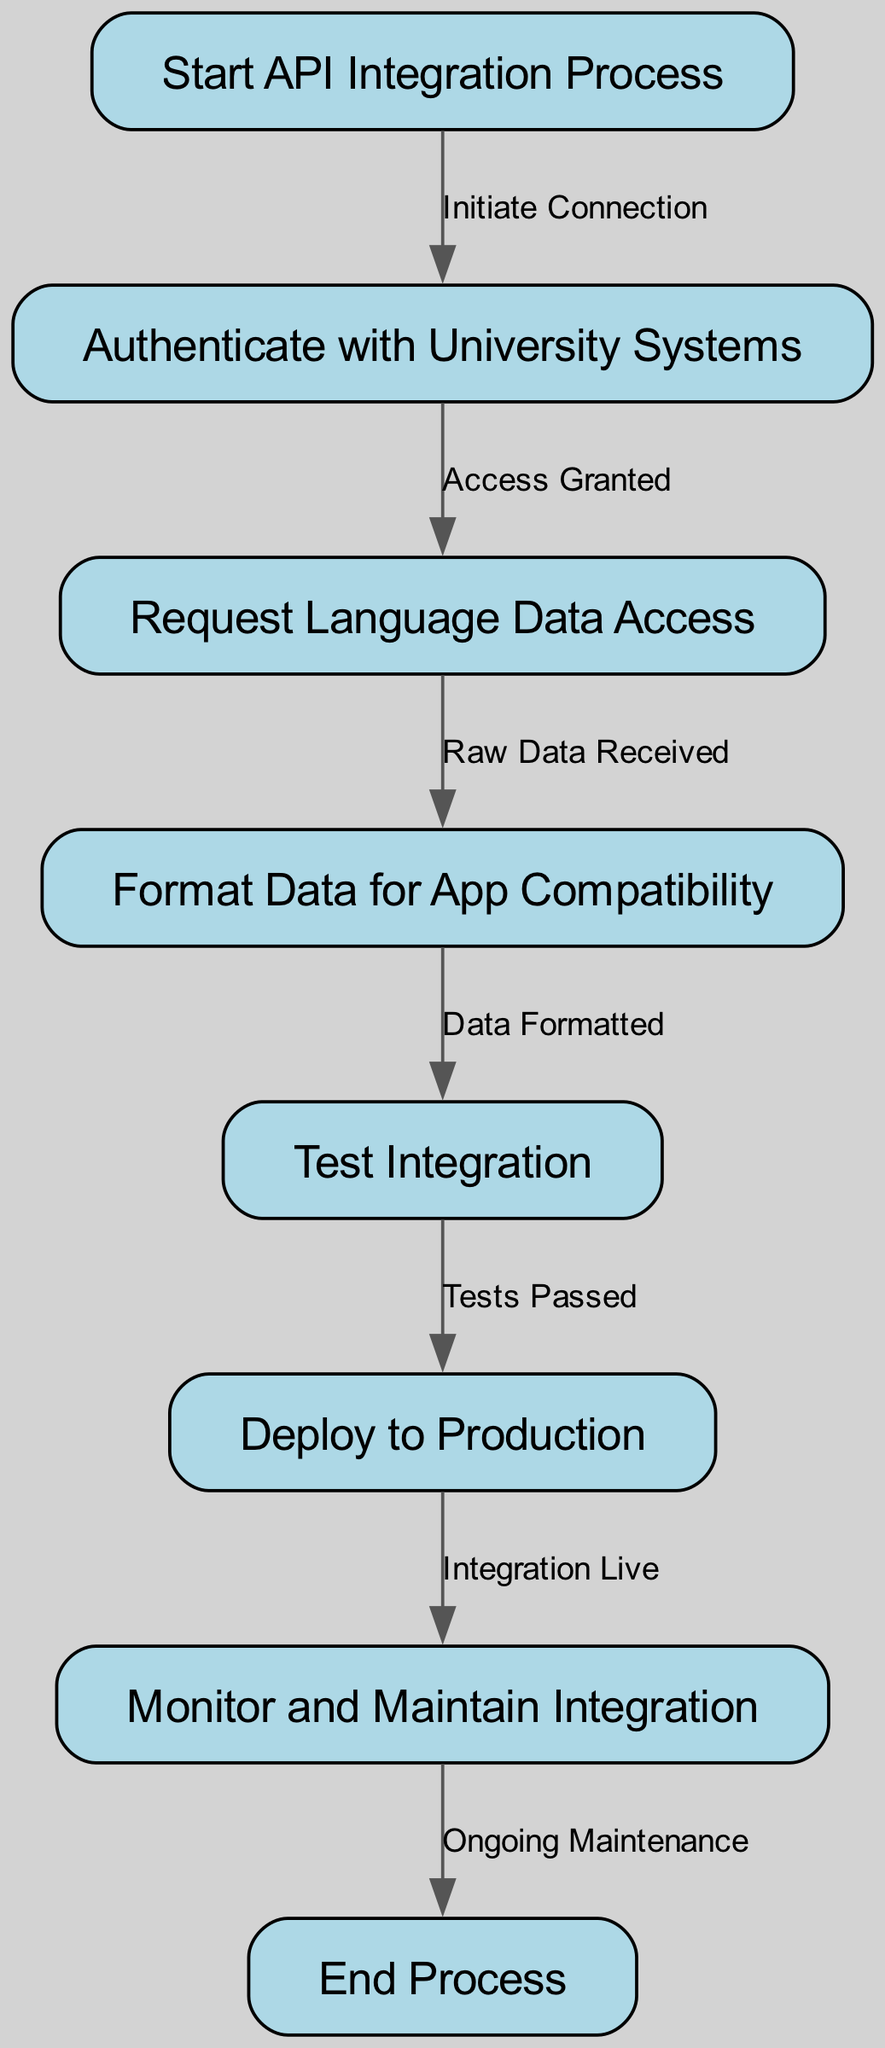What is the total number of nodes in the diagram? The diagram contains eight distinct nodes, which are labeled as 'Start API Integration Process', 'Authenticate with University Systems', 'Request Language Data Access', 'Format Data for App Compatibility', 'Test Integration', 'Deploy to Production', 'Monitor and Maintain Integration', and 'End Process'. Each corresponds to a step in the API integration workflow.
Answer: Eight What comes after 'Authenticate with University Systems'? Following 'Authenticate with University Systems', the next node in the workflow is 'Request Language Data Access', as indicated by the directed edge connecting these two nodes after access is granted.
Answer: Request Language Data Access Which node indicates the process is live? The process is indicated to be live at the 'Deploy to Production' node, which represents the step where integration is officially launched and available for use.
Answer: Deploy to Production What type of maintenance occurs after deployment? The 'Monitor and Maintain Integration' node details that ongoing maintenance occurs after deployment, emphasizing the continuous oversight required to ensure everything functions as expected.
Answer: Ongoing Maintenance How many edges connect the nodes in the diagram? There are seven edges in the diagram, connecting the eight nodes and indicating the flow from one step to the next in the API integration process. Each edge specifies the condition or action that leads to the connected node.
Answer: Seven What is the first step in the process? The first step in the process is 'Start API Integration Process', which is the initial node marking the beginning of the API integration workflow for partnering with academic institutions.
Answer: Start API Integration Process Before deploying to production, which step must be completed? Before proceeding to 'Deploy to Production', it is essential that 'Test Integration' is completed, as indicated by the directed flow from testing to deployment, which only occurs if tests are passed.
Answer: Test Integration What action initiates the connection with university systems? The action that initiates the connection with university systems is labeled as 'Initiate Connection', which is the first edge leaving the start node to the authentication step.
Answer: Initiate Connection 